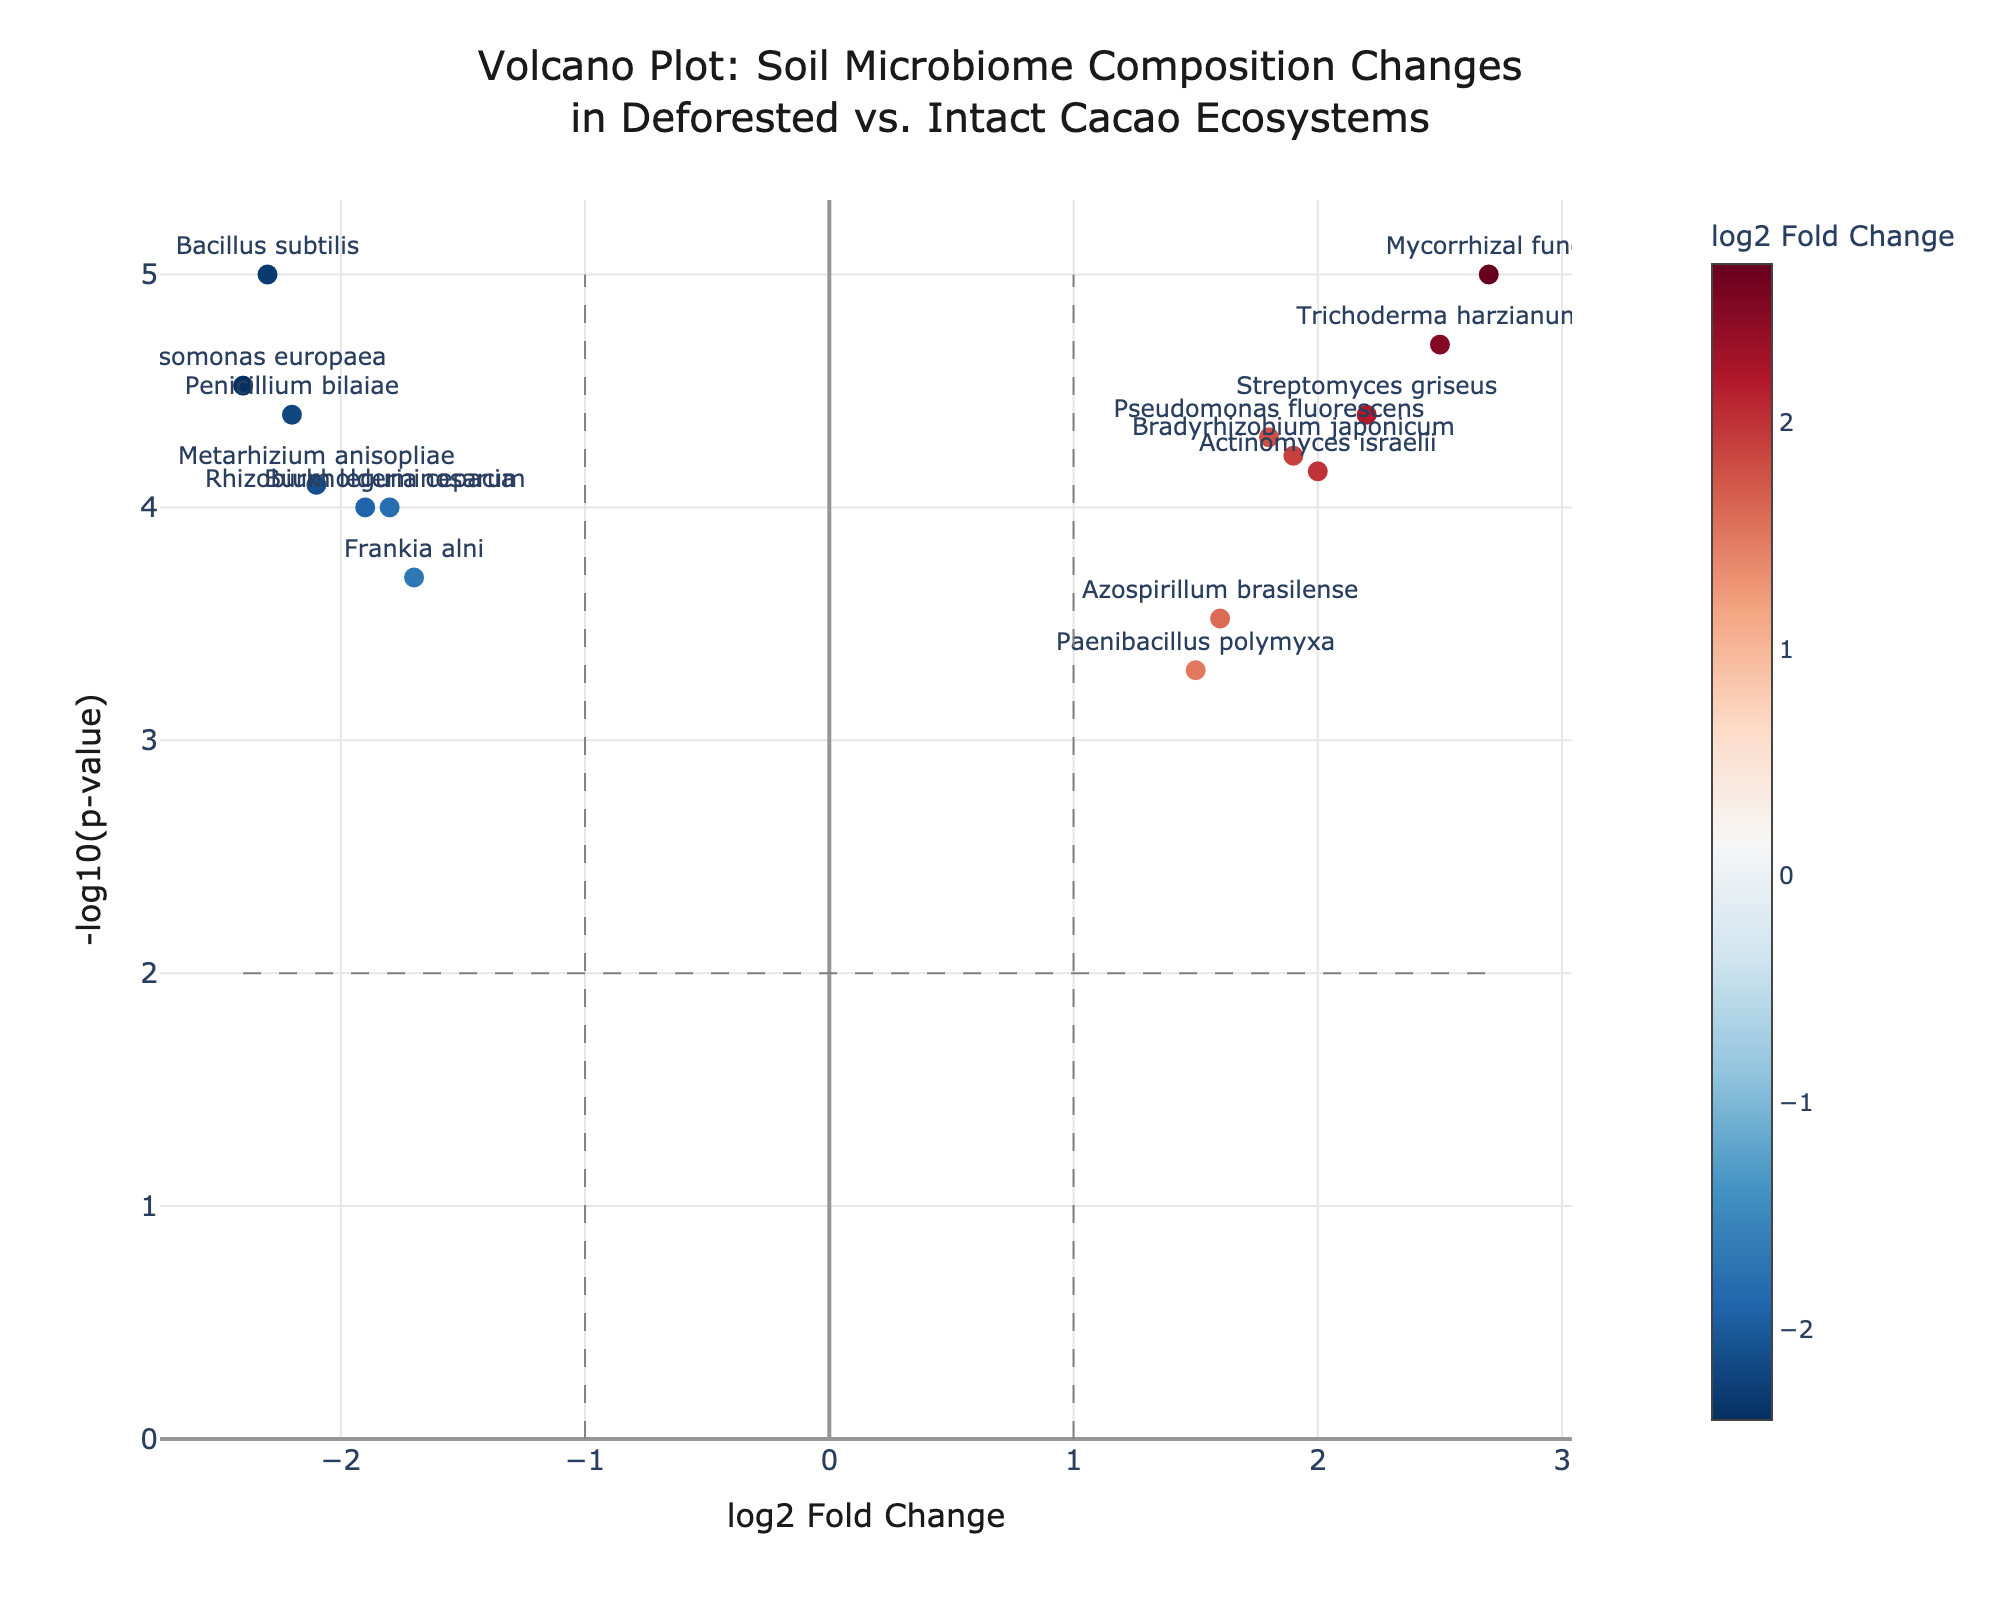What is the title of the plot? The title is placed at the top of the plot and is meant to provide a brief description of what the plot represents. It reads "Volcano Plot: Soil Microbiome Composition Changes in Deforested vs. Intact Cacao Ecosystems".
Answer: Volcano Plot: Soil Microbiome Composition Changes in Deforested vs. Intact Cacao Ecosystems How many data points have a log2 fold change greater than 1? To find this, count the data points to the right of the vertical line at log2FoldChange = 1. These points represent the genes with a positive fold change greater than 1.
Answer: 6 data points Which gene has the highest -log10(p-value)? Look for the data point that is the highest on the y-axis, which represents the -log10(p-value). The gene name displayed next to this point is the one with the highest -log10(p-value).
Answer: Mycorrhizal fungi Which gene has the most negative log2 fold change? Identify the data point that is farthest to the left on the x-axis. This point represents the gene with the most negative log2 fold change.
Answer: Bacillus subtilis Are there more genes with a positive or negative log2 fold change? Count the number of data points to the right (positive) and left (negative) of the vertical line at log2FoldChange = 0. Compare the two counts to answer the question.
Answer: More genes with a positive log2 fold change Which genes have both a log2 fold change greater than 2 and a -log10(p-value) greater than 2? Identify data points that are to the right of the vertical line at log2FoldChange = 2 and above the horizontal line at -log10(p-value) = 2.
Answer: Trichoderma harzianum and Mycorrhizal fungi What is the range of the -log10(p-value) on the y-axis? Identify the minimum and maximum values displayed on the y-axis for -log10(p-value). These values define the range.
Answer: 0 to 5 Are there any genes with a log2 fold change between -1 and 1? Identify data points that lie between the vertical lines at log2FoldChange = -1 and log2FoldChange = 1.
Answer: Yes What is the -log10(p-value) for Frankia alni? Find the data point labeled "Frankia alni" and read its y-axis value to determine the -log10(p-value).
Answer: 3.7 Which gene with a negative log2 fold change has the lowest -log10(p-value)? Identify the data point with a negative log2 fold change (left of the vertical line at log2FoldChange = 0) that is closest to the x-axis (lowest -log10(p-value)).
Answer: Burkholderia cepacia 